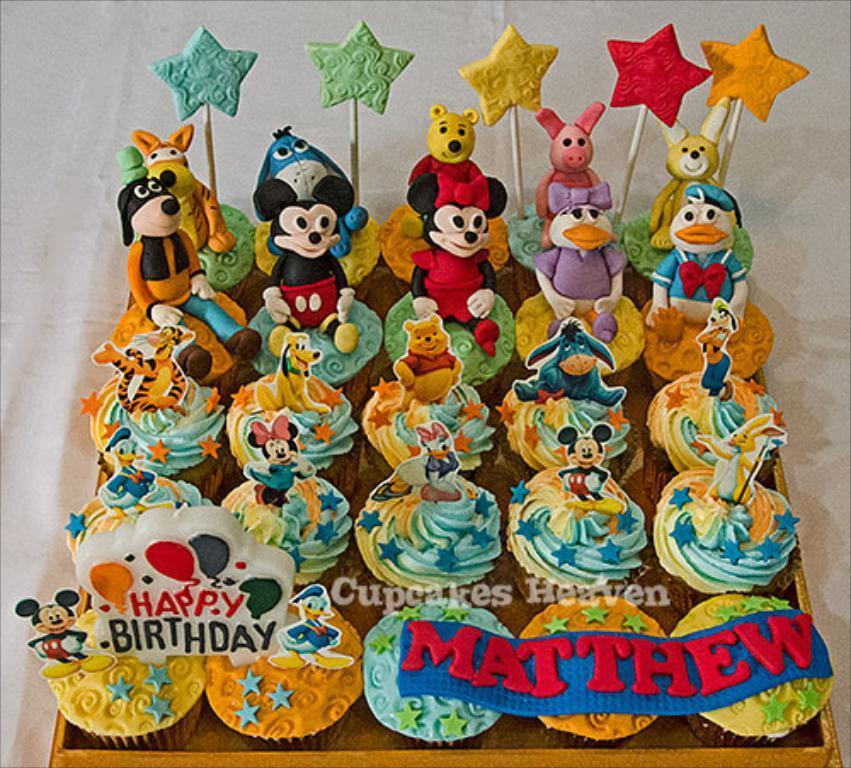Please provide a concise description of this image. In the image there is a white surface. On the white surface there is a tray with cupcakes. On the cupcakes there are cartoon images. And also there are stars in blue, green, yellow, red and orange colors. 